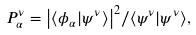Convert formula to latex. <formula><loc_0><loc_0><loc_500><loc_500>P ^ { \nu } _ { \alpha } = { \left | \langle \phi _ { \alpha } | \psi ^ { \nu } \rangle \right | ^ { 2 } } / { \langle { \psi } ^ { \nu } | \psi ^ { \nu } \rangle } ,</formula> 